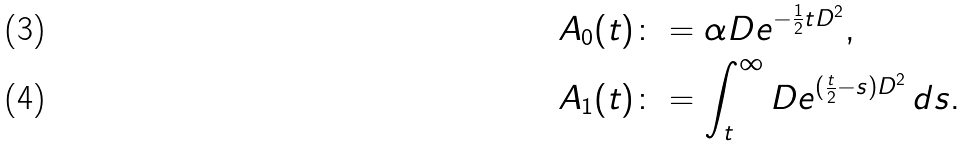<formula> <loc_0><loc_0><loc_500><loc_500>A _ { 0 } ( t ) & \colon = \alpha D e ^ { - \frac { 1 } { 2 } t D ^ { 2 } } , \\ A _ { 1 } ( t ) & \colon = \int _ { t } ^ { \infty } D e ^ { ( \frac { t } { 2 } - s ) D ^ { 2 } } \, d s .</formula> 